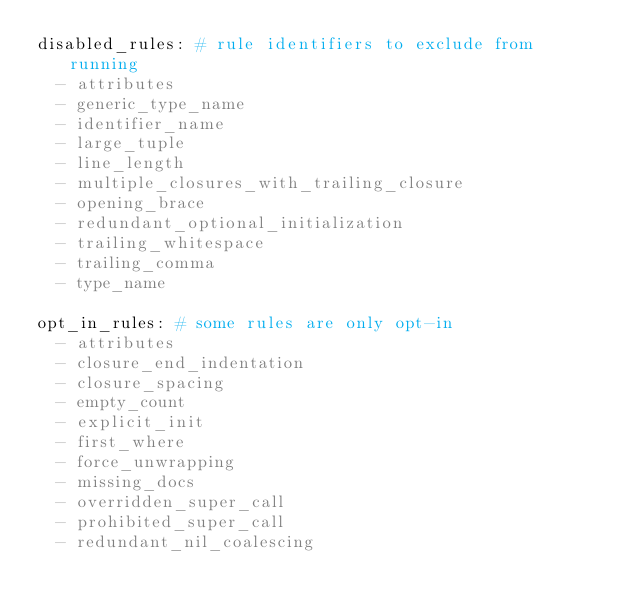<code> <loc_0><loc_0><loc_500><loc_500><_YAML_>disabled_rules: # rule identifiers to exclude from running
  - attributes
  - generic_type_name
  - identifier_name
  - large_tuple
  - line_length
  - multiple_closures_with_trailing_closure
  - opening_brace
  - redundant_optional_initialization
  - trailing_whitespace
  - trailing_comma
  - type_name

opt_in_rules: # some rules are only opt-in
  - attributes
  - closure_end_indentation
  - closure_spacing
  - empty_count
  - explicit_init
  - first_where
  - force_unwrapping
  - missing_docs
  - overridden_super_call
  - prohibited_super_call
  - redundant_nil_coalescing</code> 